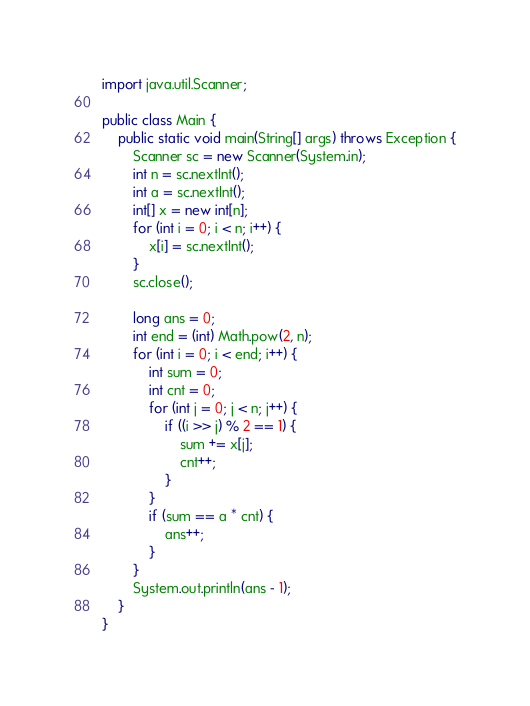<code> <loc_0><loc_0><loc_500><loc_500><_Java_>import java.util.Scanner;

public class Main {
	public static void main(String[] args) throws Exception {
		Scanner sc = new Scanner(System.in);
		int n = sc.nextInt();
		int a = sc.nextInt();
		int[] x = new int[n];
		for (int i = 0; i < n; i++) {
			x[i] = sc.nextInt();
		}
		sc.close();

		long ans = 0;
		int end = (int) Math.pow(2, n);
		for (int i = 0; i < end; i++) {
			int sum = 0;
			int cnt = 0;
			for (int j = 0; j < n; j++) {
				if ((i >> j) % 2 == 1) {
					sum += x[j];
					cnt++;
				}
			}
			if (sum == a * cnt) {
				ans++;
			}
		}
		System.out.println(ans - 1);
	}
}
</code> 